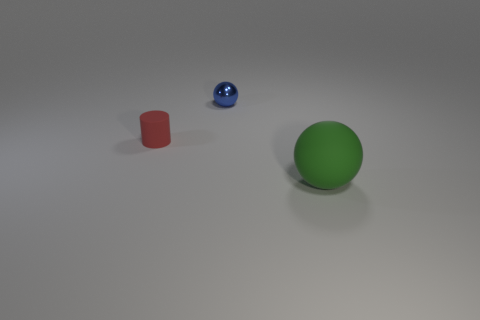Is the small object that is behind the red rubber cylinder made of the same material as the red object? While the small blue object behind the red rubber cylinder appears glossy and reflective, suggesting that it is likely made from a different material, possibly a type of polished plastic or glass. The red cylinder has a matte finish, which is characteristic of rubber materials, hence they are not made of the same material. 